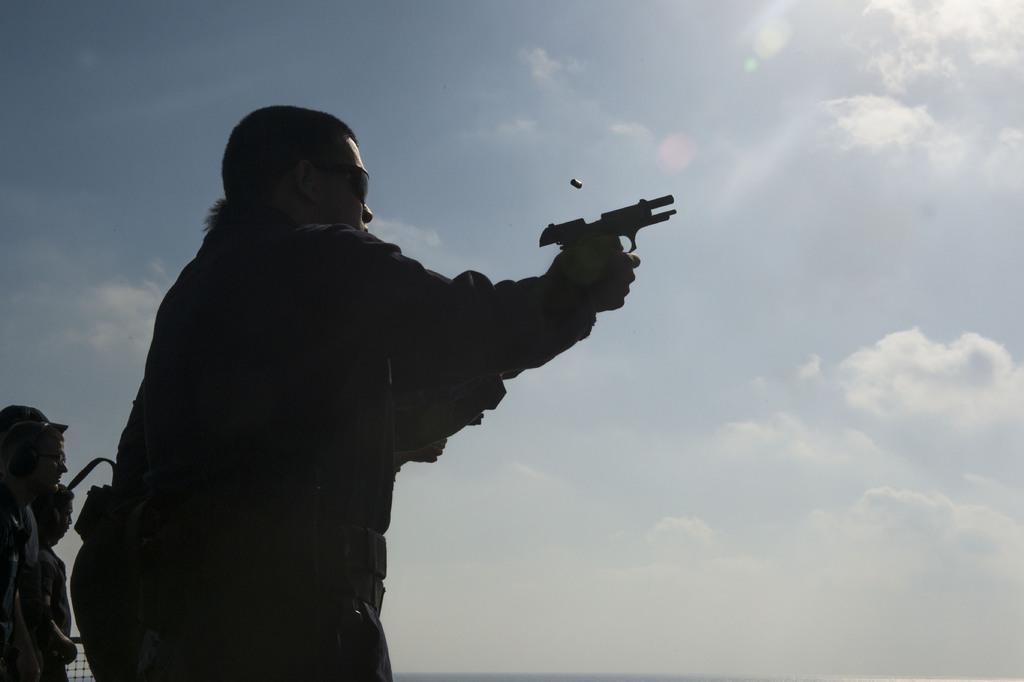How would you summarize this image in a sentence or two? This image is taken outdoors. At the top of the image there is the sky with clouds. On the left side of the image two men are standing. There is another man standing and holding a gun in his hands. 